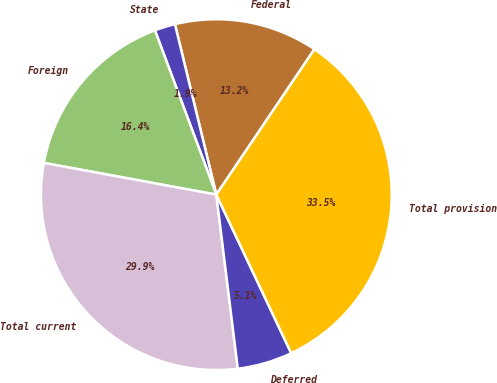Convert chart to OTSL. <chart><loc_0><loc_0><loc_500><loc_500><pie_chart><fcel>Federal<fcel>State<fcel>Foreign<fcel>Total current<fcel>Deferred<fcel>Total provision<nl><fcel>13.24%<fcel>1.9%<fcel>16.41%<fcel>29.85%<fcel>5.07%<fcel>33.53%<nl></chart> 